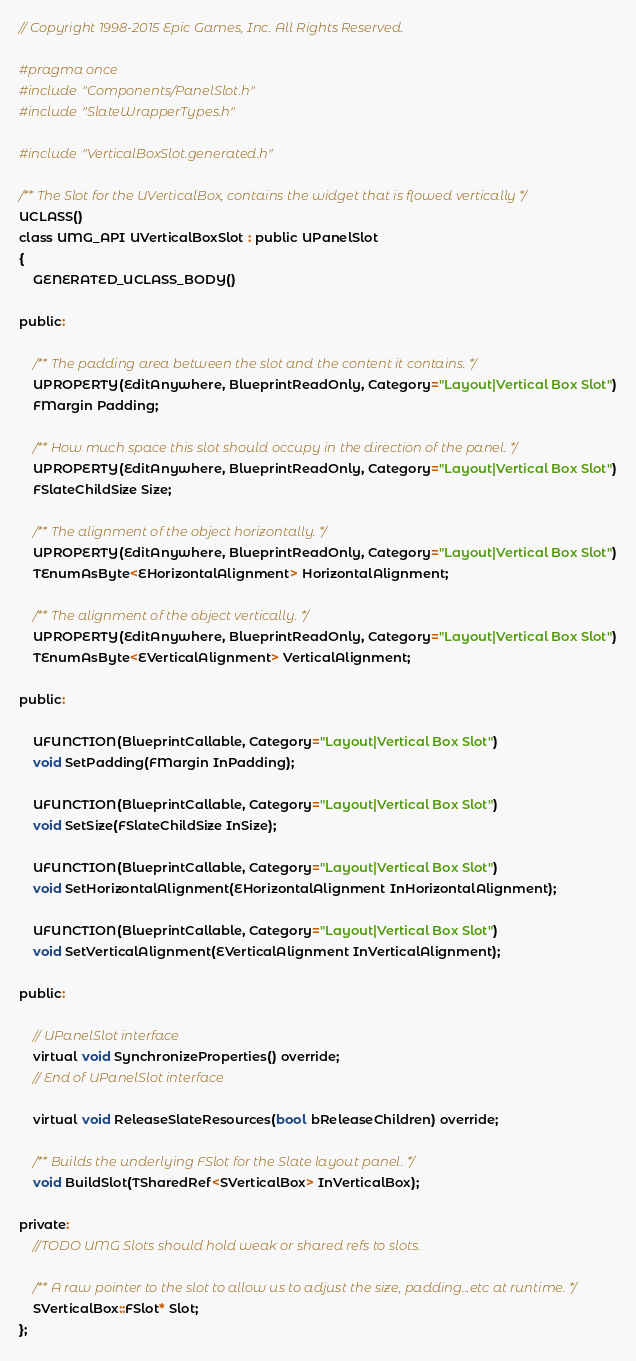Convert code to text. <code><loc_0><loc_0><loc_500><loc_500><_C_>// Copyright 1998-2015 Epic Games, Inc. All Rights Reserved.

#pragma once
#include "Components/PanelSlot.h"
#include "SlateWrapperTypes.h"

#include "VerticalBoxSlot.generated.h"

/** The Slot for the UVerticalBox, contains the widget that is flowed vertically */
UCLASS()
class UMG_API UVerticalBoxSlot : public UPanelSlot
{
	GENERATED_UCLASS_BODY()

public:
	
	/** The padding area between the slot and the content it contains. */
	UPROPERTY(EditAnywhere, BlueprintReadOnly, Category="Layout|Vertical Box Slot")
	FMargin Padding;

	/** How much space this slot should occupy in the direction of the panel. */
	UPROPERTY(EditAnywhere, BlueprintReadOnly, Category="Layout|Vertical Box Slot")
	FSlateChildSize Size;

	/** The alignment of the object horizontally. */
	UPROPERTY(EditAnywhere, BlueprintReadOnly, Category="Layout|Vertical Box Slot")
	TEnumAsByte<EHorizontalAlignment> HorizontalAlignment;

	/** The alignment of the object vertically. */
	UPROPERTY(EditAnywhere, BlueprintReadOnly, Category="Layout|Vertical Box Slot")
	TEnumAsByte<EVerticalAlignment> VerticalAlignment;

public:

	UFUNCTION(BlueprintCallable, Category="Layout|Vertical Box Slot")
	void SetPadding(FMargin InPadding);

	UFUNCTION(BlueprintCallable, Category="Layout|Vertical Box Slot")
	void SetSize(FSlateChildSize InSize);

	UFUNCTION(BlueprintCallable, Category="Layout|Vertical Box Slot")
	void SetHorizontalAlignment(EHorizontalAlignment InHorizontalAlignment);

	UFUNCTION(BlueprintCallable, Category="Layout|Vertical Box Slot")
	void SetVerticalAlignment(EVerticalAlignment InVerticalAlignment);

public:

	// UPanelSlot interface
	virtual void SynchronizeProperties() override;
	// End of UPanelSlot interface

	virtual void ReleaseSlateResources(bool bReleaseChildren) override;

	/** Builds the underlying FSlot for the Slate layout panel. */
	void BuildSlot(TSharedRef<SVerticalBox> InVerticalBox);

private:
	//TODO UMG Slots should hold weak or shared refs to slots.

	/** A raw pointer to the slot to allow us to adjust the size, padding...etc at runtime. */
	SVerticalBox::FSlot* Slot;
};
</code> 